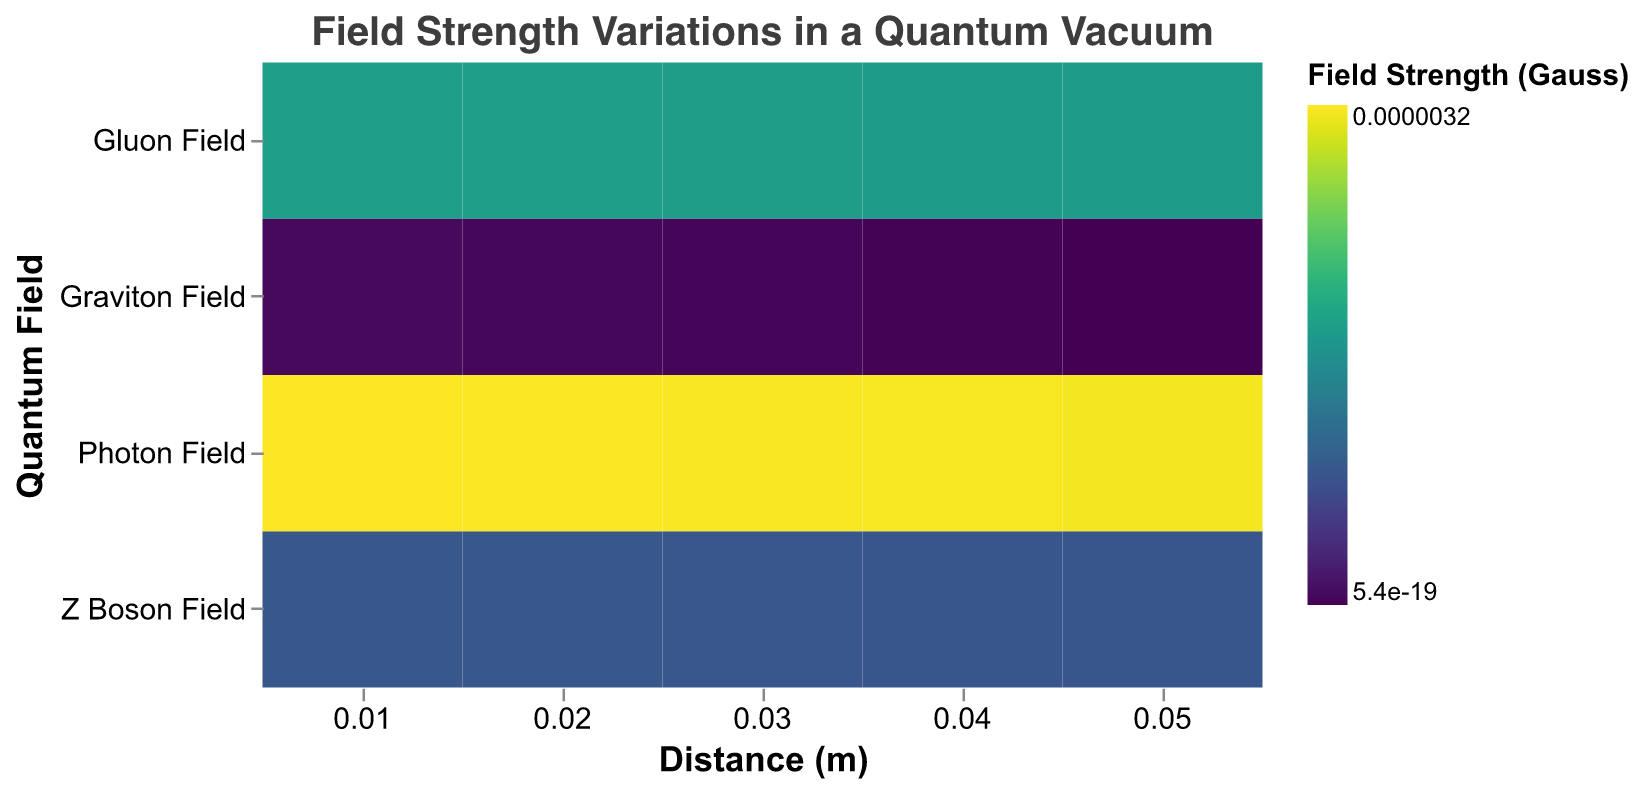What is the title of the heatmap? The title is displayed at the top of the heatmap, specifying the subject of the visualization. The title reads "Field Strength Variations in a Quantum Vacuum."
Answer: Field Strength Variations in a Quantum Vacuum How many quantum fields are represented in the heatmap? The y-axis lists the quantum fields that are represented in the heatmap. By counting the distinct entries along the y-axis, we can see there are four quantum fields: "Z Boson Field," "Photon Field," "Gluon Field," and "Graviton Field."
Answer: 4 Which field shows the highest strength at 0.01 meters? By locating the x-axis value of 0.01 meters and comparing the color intensity, the "Photon Field" has the highest strength as indicated by the most intense color at this distance.
Answer: Photon Field How does the strength of the Z Boson Field change as the distance increases from 0.01 meters to 0.05 meters? Observing the color gradient of the "Z Boson Field" row across the x-axis from 0.01 meters to 0.05 meters, the color gets progressively lighter. This indicates that the strength of the Z Boson Field decreases as the distance increases.
Answer: Decreases Compare the strength of the Photon Field and the Gluon Field at a distance of 0.03 meters. Which one is stronger? By examining the color intensity for both fields at 0.03 meters on the x-axis, the Photon Field's color is more intense than the Gluon Field's, indicating higher strength.
Answer: Photon Field What is the primary color scheme used to represent field strength, and what type of scale is applied? The heatmap color bar shows a gradient from dark to light, corresponding to strength values. The legend indicates a "viridis" color scheme, and a log scale is applied to the field strength values.
Answer: Viridis, log scale What is the average strength of the Graviton Field over the distances provided? The Graviton Field strengths at different distances are: 9.8e-19, 8.7e-19, 7.6e-19, 6.5e-19, 5.4e-19. Their sum is 38e-19, and the average is 38e-19 / 5 = 7.6e-19
Answer: 7.6e-19 Which quantum field shows the smallest decrease in strength from 0.01 meters to 0.05 meters? For each field, we observe the color transition from 0.01 meters to 0.05 meters. The Graviton Field shows the flatter color gradient, indicating the smallest decrease in strength compared to the other fields.
Answer: Graviton Field 